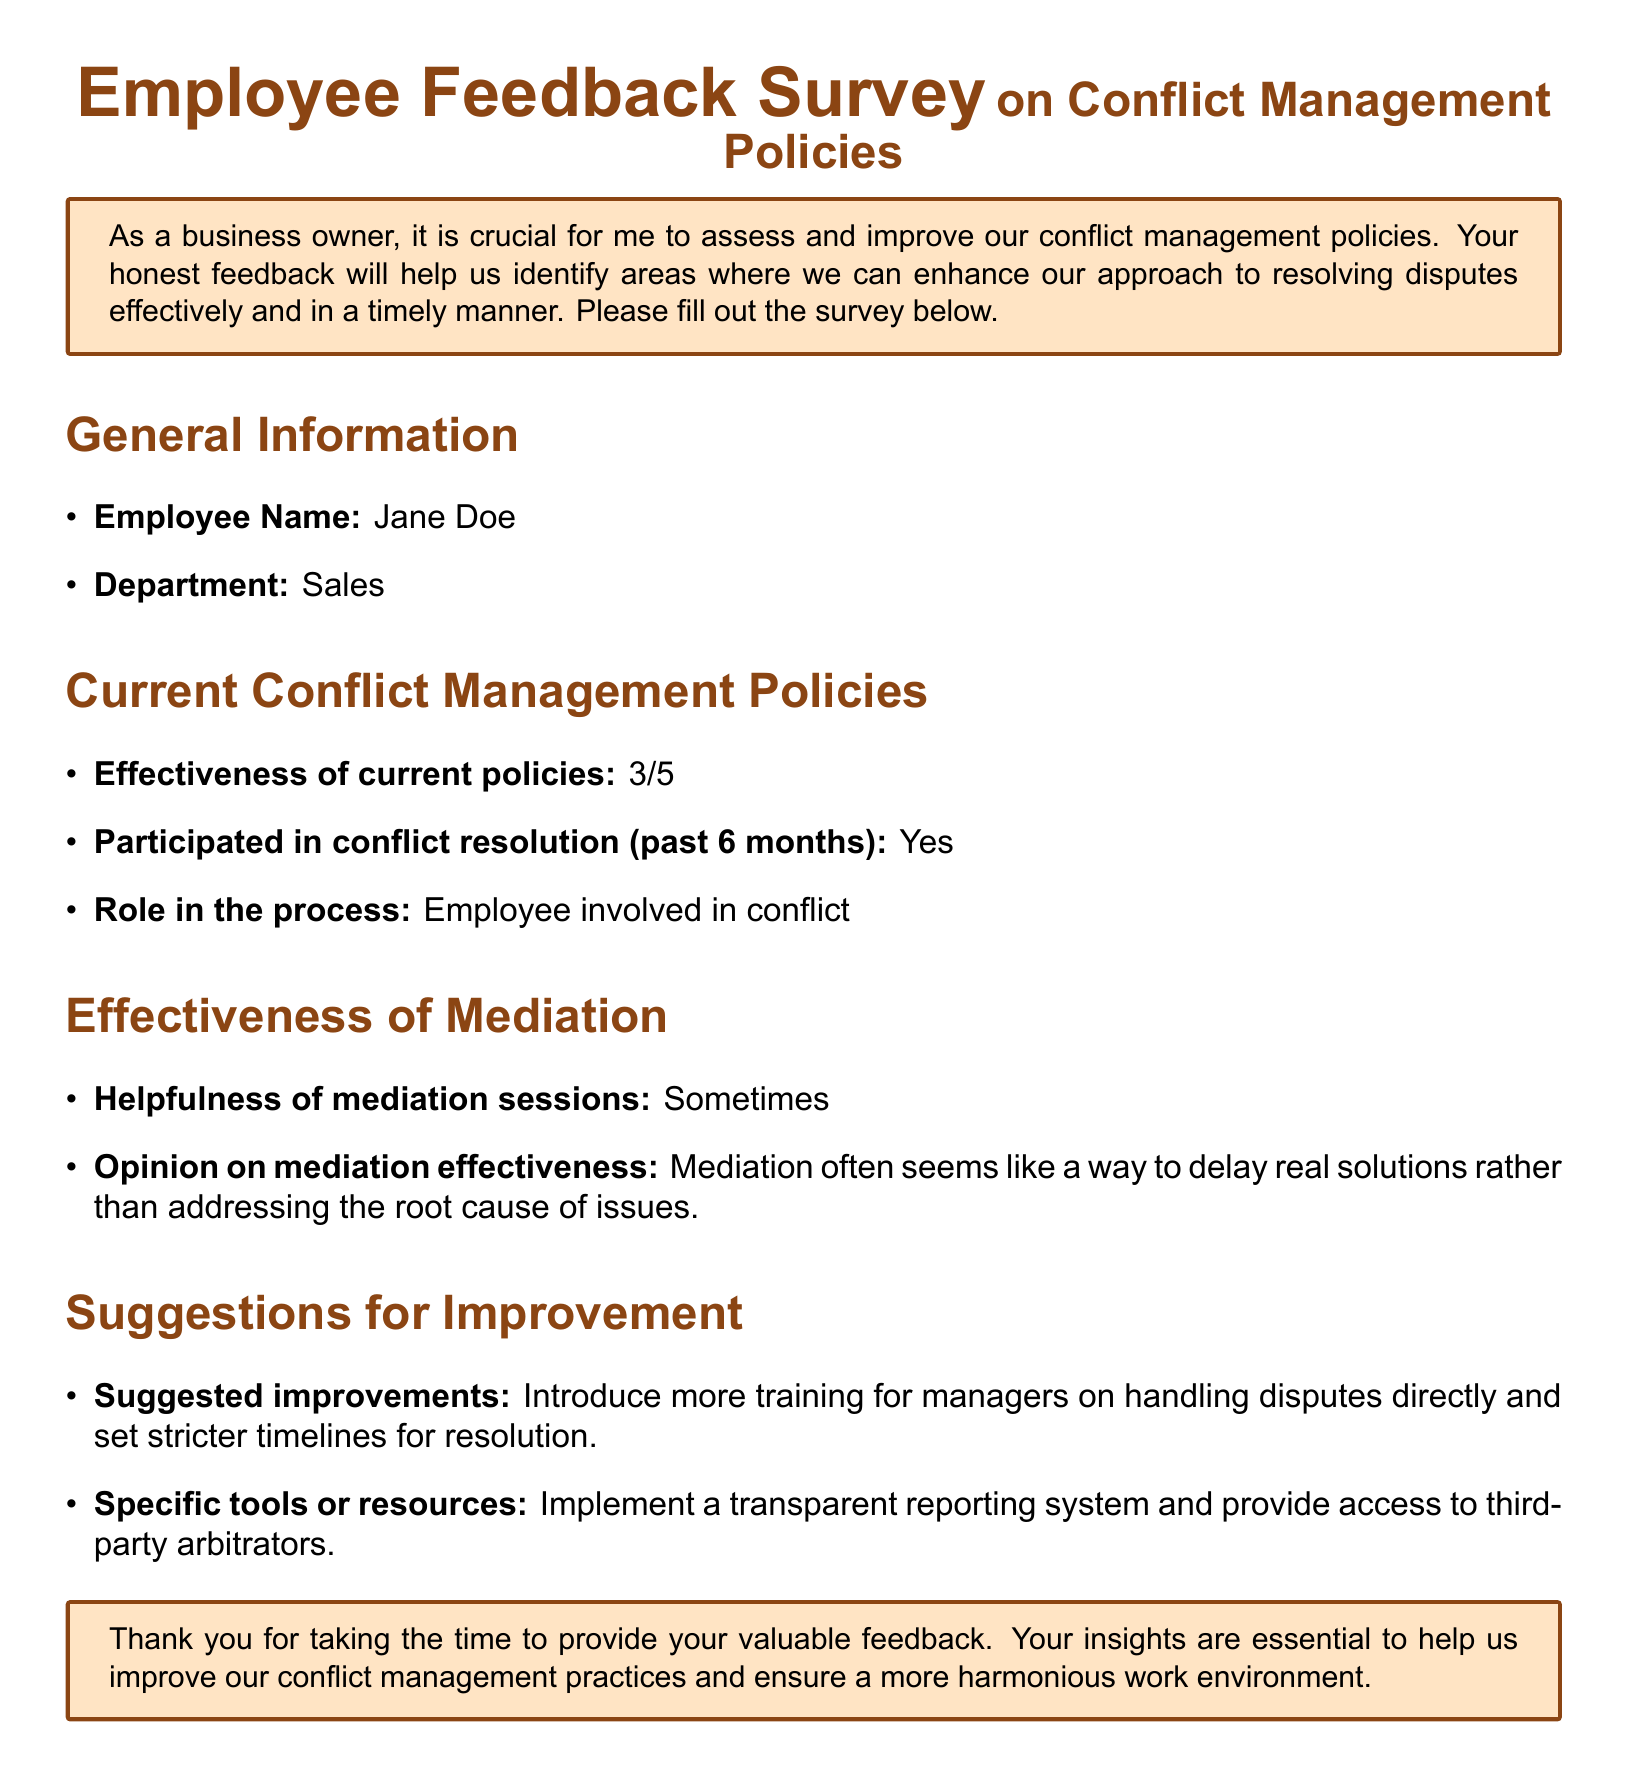What is the employee's name? The document states that the employee's name is given in the general information section.
Answer: Jane Doe What department does the employee work in? According to the general information, the employee's department is specified.
Answer: Sales How effective are the current conflict management policies? The effectiveness rating of the current policy is provided in the document.
Answer: 3/5 Has the employee participated in conflict resolution in the past 6 months? The document mentions whether the employee has been involved in conflict resolution recently.
Answer: Yes What is the employee's opinion on mediation effectiveness? The opinion on mediation effectiveness is detailed in the effectiveness of mediation section.
Answer: Mediation often seems like a way to delay real solutions rather than addressing the root cause of issues What improvements are suggested for conflict management? The suggested improvements are listed in the suggestions for improvement section of the document.
Answer: Introduce more training for managers on handling disputes directly and set stricter timelines for resolution What tools or resources does the employee recommend? The specific tools or resources suggested by the employee are indicated in the suggestions for improvement section.
Answer: Implement a transparent reporting system and provide access to third-party arbitrators What role did the employee have in the conflict resolution process? The employee's role in the process is mentioned in the current conflict management policies section.
Answer: Employee involved in conflict 